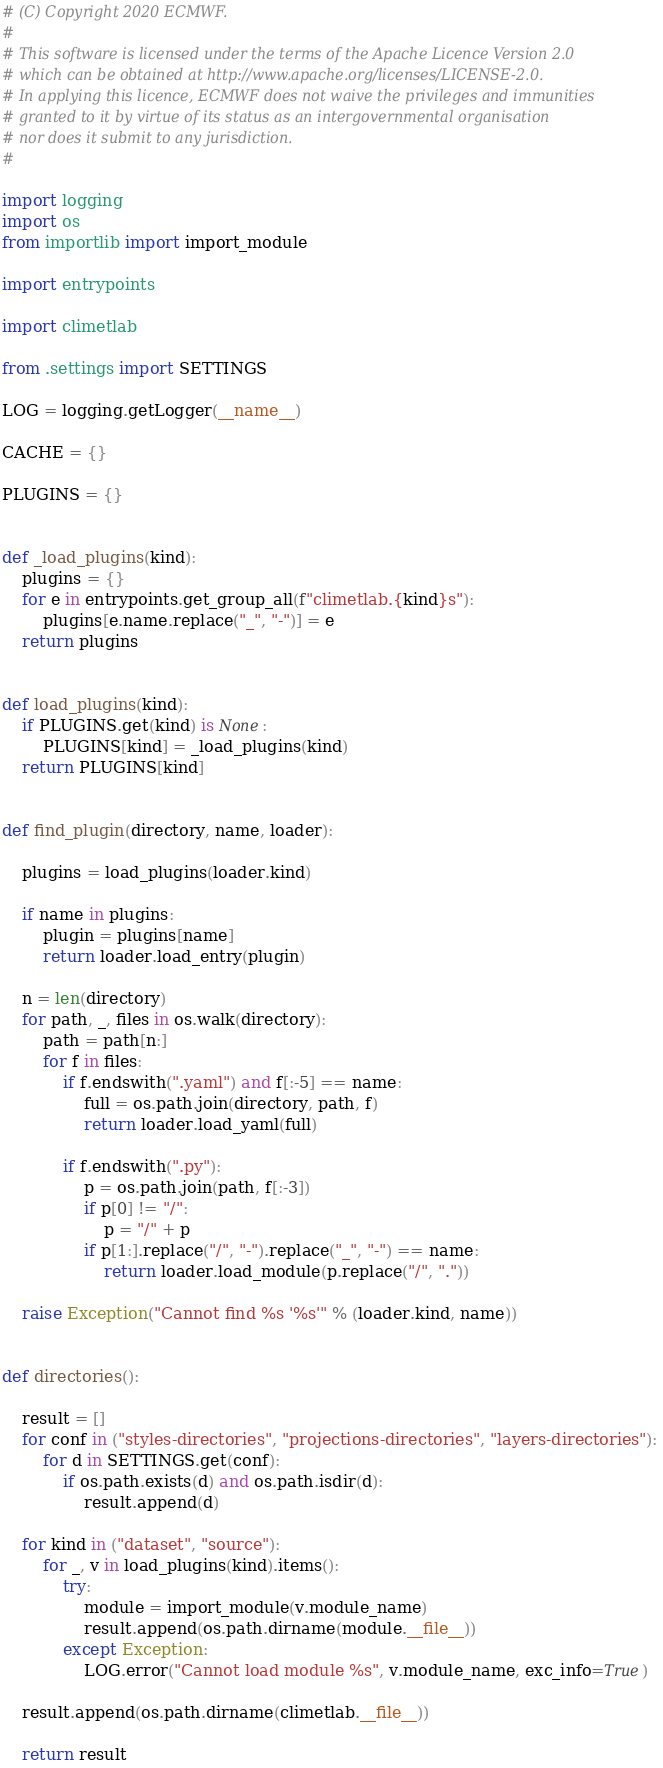Convert code to text. <code><loc_0><loc_0><loc_500><loc_500><_Python_># (C) Copyright 2020 ECMWF.
#
# This software is licensed under the terms of the Apache Licence Version 2.0
# which can be obtained at http://www.apache.org/licenses/LICENSE-2.0.
# In applying this licence, ECMWF does not waive the privileges and immunities
# granted to it by virtue of its status as an intergovernmental organisation
# nor does it submit to any jurisdiction.
#

import logging
import os
from importlib import import_module

import entrypoints

import climetlab

from .settings import SETTINGS

LOG = logging.getLogger(__name__)

CACHE = {}

PLUGINS = {}


def _load_plugins(kind):
    plugins = {}
    for e in entrypoints.get_group_all(f"climetlab.{kind}s"):
        plugins[e.name.replace("_", "-")] = e
    return plugins


def load_plugins(kind):
    if PLUGINS.get(kind) is None:
        PLUGINS[kind] = _load_plugins(kind)
    return PLUGINS[kind]


def find_plugin(directory, name, loader):

    plugins = load_plugins(loader.kind)

    if name in plugins:
        plugin = plugins[name]
        return loader.load_entry(plugin)

    n = len(directory)
    for path, _, files in os.walk(directory):
        path = path[n:]
        for f in files:
            if f.endswith(".yaml") and f[:-5] == name:
                full = os.path.join(directory, path, f)
                return loader.load_yaml(full)

            if f.endswith(".py"):
                p = os.path.join(path, f[:-3])
                if p[0] != "/":
                    p = "/" + p
                if p[1:].replace("/", "-").replace("_", "-") == name:
                    return loader.load_module(p.replace("/", "."))

    raise Exception("Cannot find %s '%s'" % (loader.kind, name))


def directories():

    result = []
    for conf in ("styles-directories", "projections-directories", "layers-directories"):
        for d in SETTINGS.get(conf):
            if os.path.exists(d) and os.path.isdir(d):
                result.append(d)

    for kind in ("dataset", "source"):
        for _, v in load_plugins(kind).items():
            try:
                module = import_module(v.module_name)
                result.append(os.path.dirname(module.__file__))
            except Exception:
                LOG.error("Cannot load module %s", v.module_name, exc_info=True)

    result.append(os.path.dirname(climetlab.__file__))

    return result
</code> 